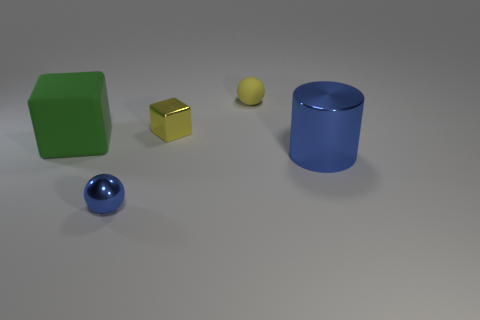What material is the sphere that is the same color as the big metallic object?
Offer a very short reply. Metal. How many things have the same color as the small cube?
Provide a short and direct response. 1. Does the tiny yellow thing that is in front of the yellow rubber object have the same material as the big thing that is to the left of the tiny metal block?
Give a very brief answer. No. The other yellow thing that is the same size as the yellow rubber object is what shape?
Ensure brevity in your answer.  Cube. Are there any brown matte objects that have the same shape as the green thing?
Offer a very short reply. No. There is a tiny ball that is left of the small yellow shiny object; does it have the same color as the rubber object on the right side of the large matte cube?
Offer a terse response. No. Are there any big blue shiny cylinders on the right side of the blue shiny cylinder?
Offer a very short reply. No. There is a thing that is both behind the big blue metallic cylinder and in front of the yellow metal thing; what material is it made of?
Give a very brief answer. Rubber. Are the tiny object that is right of the small yellow shiny cube and the green thing made of the same material?
Make the answer very short. Yes. What is the material of the tiny block?
Keep it short and to the point. Metal. 